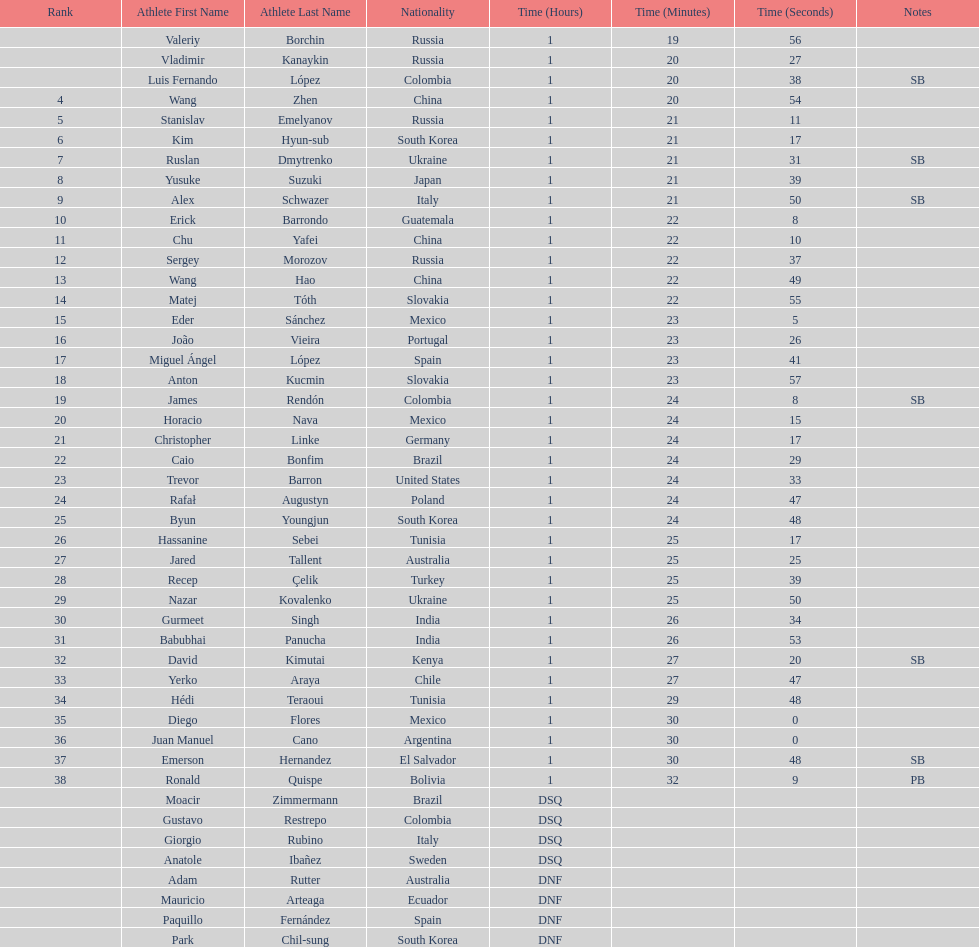How many russians finished at least 3rd in the 20km walk? 2. 